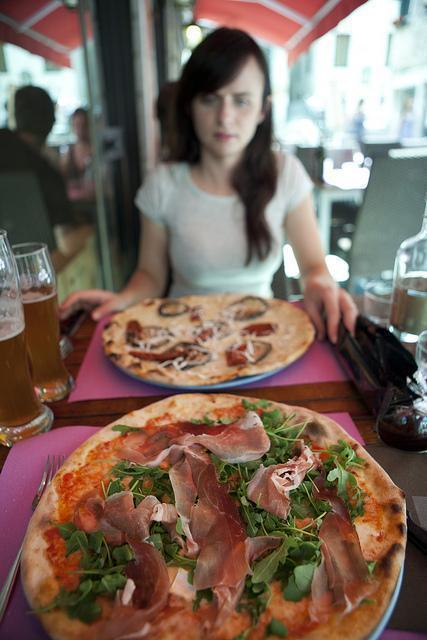How many pizzas can you see?
Give a very brief answer. 2. How many people can you see?
Give a very brief answer. 3. How many cups are there?
Give a very brief answer. 2. 